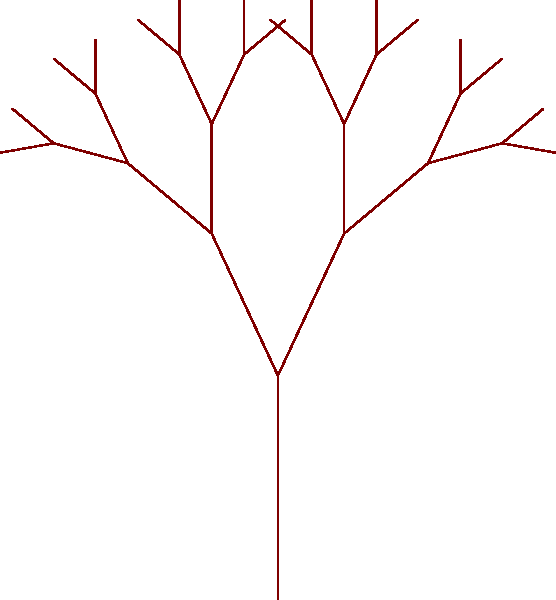Consider a fractal tree model where each branch splits into two smaller branches, each 70% the length of the parent branch. If the initial trunk length is 100 cm, what is the total length of all branches at the 4th iteration (including the trunk)? Let's approach this step-by-step:

1) First, let's calculate the length of branches at each iteration:
   - Iteration 0 (trunk): 100 cm
   - Iteration 1: $100 \times 0.7 = 70$ cm
   - Iteration 2: $70 \times 0.7 = 49$ cm
   - Iteration 3: $49 \times 0.7 = 34.3$ cm
   - Iteration 4: $34.3 \times 0.7 = 24.01$ cm

2) Now, let's count the number of branches at each iteration:
   - Iteration 0: 1 branch
   - Iteration 1: 2 branches
   - Iteration 2: 4 branches
   - Iteration 3: 8 branches
   - Iteration 4: 16 branches

3) Calculate the total length at each iteration:
   - Iteration 0: $1 \times 100 = 100$ cm
   - Iteration 1: $2 \times 70 = 140$ cm
   - Iteration 2: $4 \times 49 = 196$ cm
   - Iteration 3: $8 \times 34.3 = 274.4$ cm
   - Iteration 4: $16 \times 24.01 = 384.16$ cm

4) Sum up the total length of all branches:
   $100 + 140 + 196 + 274.4 + 384.16 = 1094.56$ cm

Therefore, the total length of all branches at the 4th iteration is approximately 1094.56 cm.
Answer: 1094.56 cm 